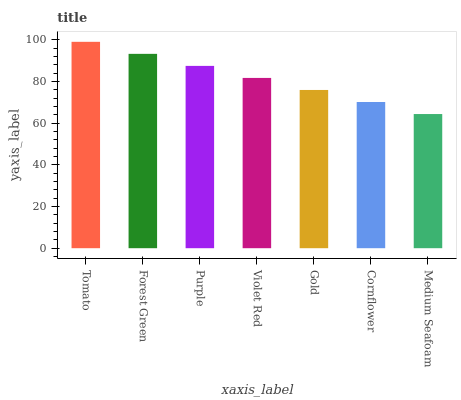Is Medium Seafoam the minimum?
Answer yes or no. Yes. Is Tomato the maximum?
Answer yes or no. Yes. Is Forest Green the minimum?
Answer yes or no. No. Is Forest Green the maximum?
Answer yes or no. No. Is Tomato greater than Forest Green?
Answer yes or no. Yes. Is Forest Green less than Tomato?
Answer yes or no. Yes. Is Forest Green greater than Tomato?
Answer yes or no. No. Is Tomato less than Forest Green?
Answer yes or no. No. Is Violet Red the high median?
Answer yes or no. Yes. Is Violet Red the low median?
Answer yes or no. Yes. Is Forest Green the high median?
Answer yes or no. No. Is Gold the low median?
Answer yes or no. No. 